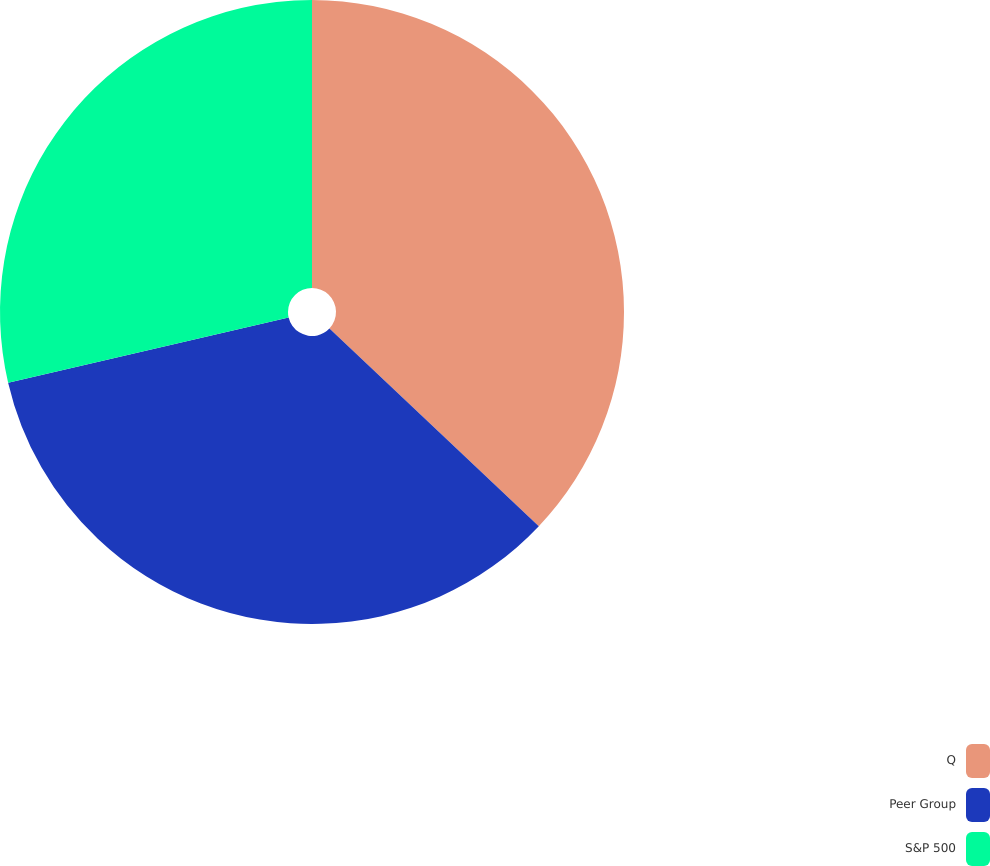Convert chart. <chart><loc_0><loc_0><loc_500><loc_500><pie_chart><fcel>Q<fcel>Peer Group<fcel>S&P 500<nl><fcel>37.05%<fcel>34.32%<fcel>28.64%<nl></chart> 